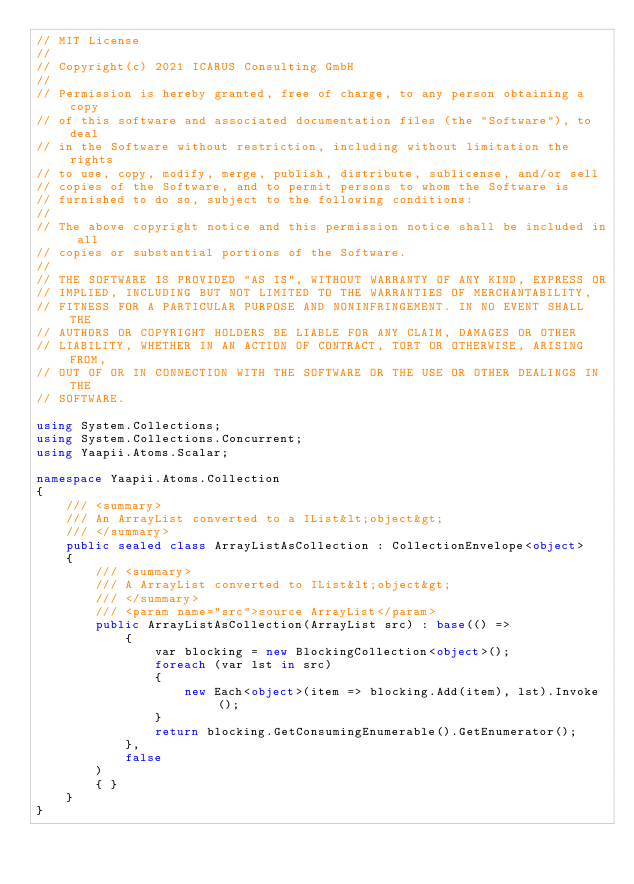<code> <loc_0><loc_0><loc_500><loc_500><_C#_>// MIT License
//
// Copyright(c) 2021 ICARUS Consulting GmbH
//
// Permission is hereby granted, free of charge, to any person obtaining a copy
// of this software and associated documentation files (the "Software"), to deal
// in the Software without restriction, including without limitation the rights
// to use, copy, modify, merge, publish, distribute, sublicense, and/or sell
// copies of the Software, and to permit persons to whom the Software is
// furnished to do so, subject to the following conditions:
//
// The above copyright notice and this permission notice shall be included in all
// copies or substantial portions of the Software.
//
// THE SOFTWARE IS PROVIDED "AS IS", WITHOUT WARRANTY OF ANY KIND, EXPRESS OR
// IMPLIED, INCLUDING BUT NOT LIMITED TO THE WARRANTIES OF MERCHANTABILITY,
// FITNESS FOR A PARTICULAR PURPOSE AND NONINFRINGEMENT. IN NO EVENT SHALL THE
// AUTHORS OR COPYRIGHT HOLDERS BE LIABLE FOR ANY CLAIM, DAMAGES OR OTHER
// LIABILITY, WHETHER IN AN ACTION OF CONTRACT, TORT OR OTHERWISE, ARISING FROM,
// OUT OF OR IN CONNECTION WITH THE SOFTWARE OR THE USE OR OTHER DEALINGS IN THE
// SOFTWARE.

using System.Collections;
using System.Collections.Concurrent;
using Yaapii.Atoms.Scalar;

namespace Yaapii.Atoms.Collection
{
    /// <summary>
    /// An ArrayList converted to a IList&lt;object&gt;
    /// </summary>
    public sealed class ArrayListAsCollection : CollectionEnvelope<object>
    {
        /// <summary>
        /// A ArrayList converted to IList&lt;object&gt;
        /// </summary>
        /// <param name="src">source ArrayList</param>
        public ArrayListAsCollection(ArrayList src) : base(() =>
            {
                var blocking = new BlockingCollection<object>();
                foreach (var lst in src)
                {
                    new Each<object>(item => blocking.Add(item), lst).Invoke();
                }
                return blocking.GetConsumingEnumerable().GetEnumerator();
            },
            false
        )
        { }
    }
}
</code> 